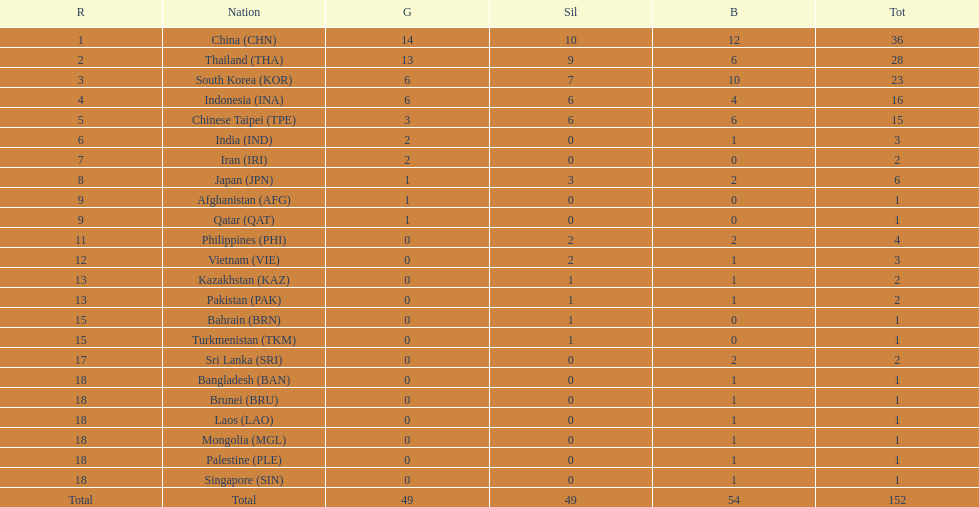Which countries won the same number of gold medals as japan? Afghanistan (AFG), Qatar (QAT). 